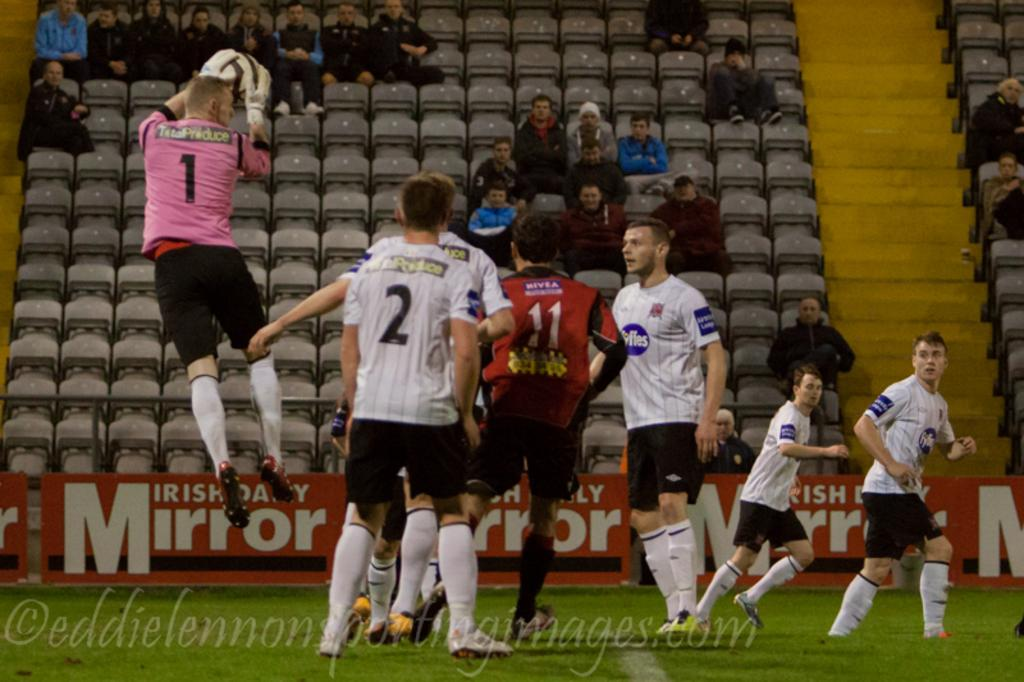<image>
Provide a brief description of the given image. a soccer field with a player wearing the number 2 